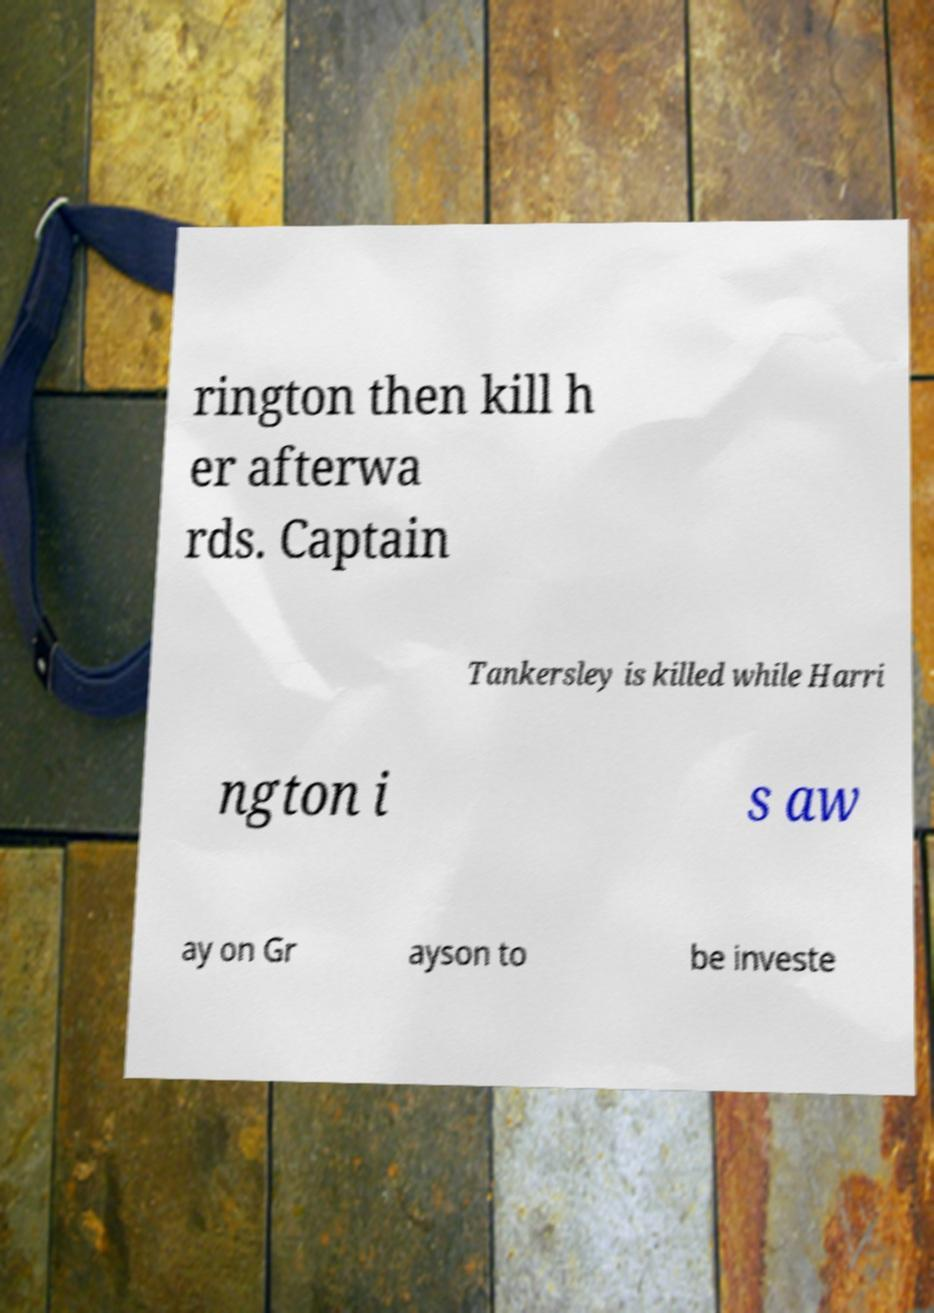Please identify and transcribe the text found in this image. rington then kill h er afterwa rds. Captain Tankersley is killed while Harri ngton i s aw ay on Gr ayson to be investe 